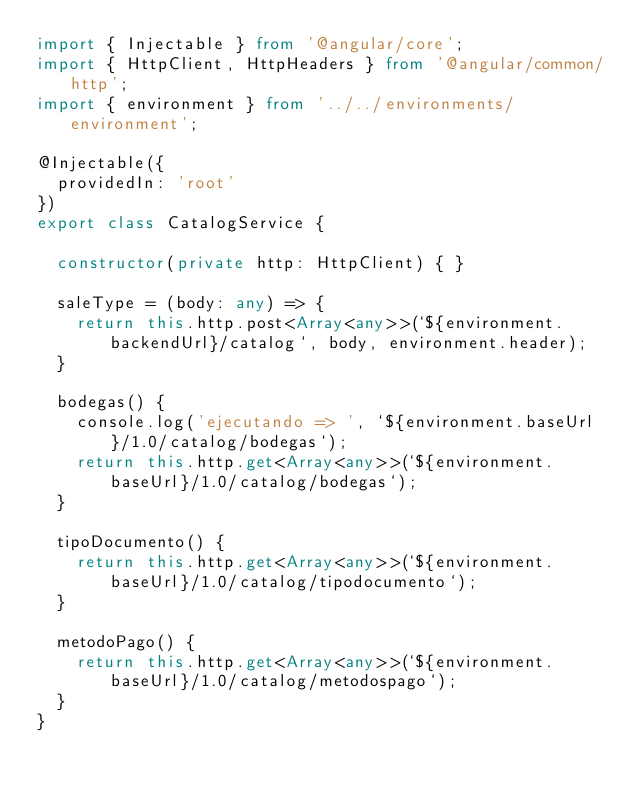<code> <loc_0><loc_0><loc_500><loc_500><_TypeScript_>import { Injectable } from '@angular/core';
import { HttpClient, HttpHeaders } from '@angular/common/http';
import { environment } from '../../environments/environment';

@Injectable({
  providedIn: 'root'
})
export class CatalogService {

  constructor(private http: HttpClient) { }

  saleType = (body: any) => {
    return this.http.post<Array<any>>(`${environment.backendUrl}/catalog`, body, environment.header);
  }

  bodegas() {
    console.log('ejecutando => ', `${environment.baseUrl}/1.0/catalog/bodegas`);
    return this.http.get<Array<any>>(`${environment.baseUrl}/1.0/catalog/bodegas`);
  }

  tipoDocumento() {
    return this.http.get<Array<any>>(`${environment.baseUrl}/1.0/catalog/tipodocumento`);
  }

  metodoPago() {
    return this.http.get<Array<any>>(`${environment.baseUrl}/1.0/catalog/metodospago`);
  }
}
</code> 